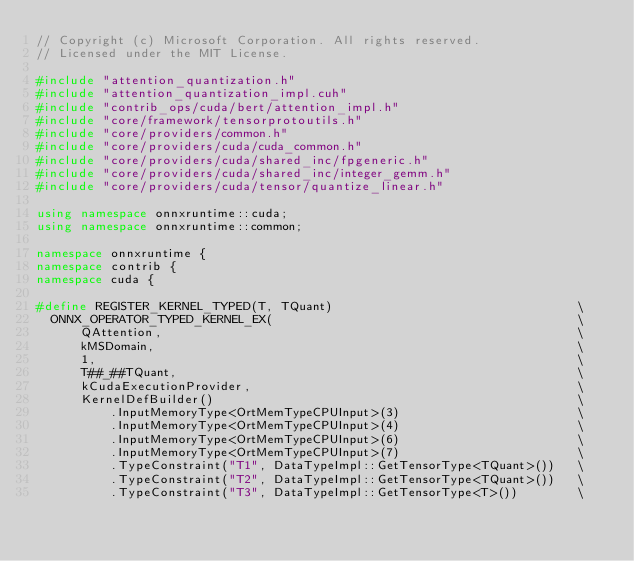<code> <loc_0><loc_0><loc_500><loc_500><_C++_>// Copyright (c) Microsoft Corporation. All rights reserved.
// Licensed under the MIT License.

#include "attention_quantization.h"
#include "attention_quantization_impl.cuh"
#include "contrib_ops/cuda/bert/attention_impl.h"
#include "core/framework/tensorprotoutils.h"
#include "core/providers/common.h"
#include "core/providers/cuda/cuda_common.h"
#include "core/providers/cuda/shared_inc/fpgeneric.h"
#include "core/providers/cuda/shared_inc/integer_gemm.h"
#include "core/providers/cuda/tensor/quantize_linear.h"

using namespace onnxruntime::cuda;
using namespace onnxruntime::common;

namespace onnxruntime {
namespace contrib {
namespace cuda {

#define REGISTER_KERNEL_TYPED(T, TQuant)                                 \
  ONNX_OPERATOR_TYPED_KERNEL_EX(                                         \
      QAttention,                                                        \
      kMSDomain,                                                         \
      1,                                                                 \
      T##_##TQuant,                                                      \
      kCudaExecutionProvider,                                            \
      KernelDefBuilder()                                                 \
          .InputMemoryType<OrtMemTypeCPUInput>(3)                        \
          .InputMemoryType<OrtMemTypeCPUInput>(4)                        \
          .InputMemoryType<OrtMemTypeCPUInput>(6)                        \
          .InputMemoryType<OrtMemTypeCPUInput>(7)                        \
          .TypeConstraint("T1", DataTypeImpl::GetTensorType<TQuant>())   \
          .TypeConstraint("T2", DataTypeImpl::GetTensorType<TQuant>())   \
          .TypeConstraint("T3", DataTypeImpl::GetTensorType<T>())        \</code> 